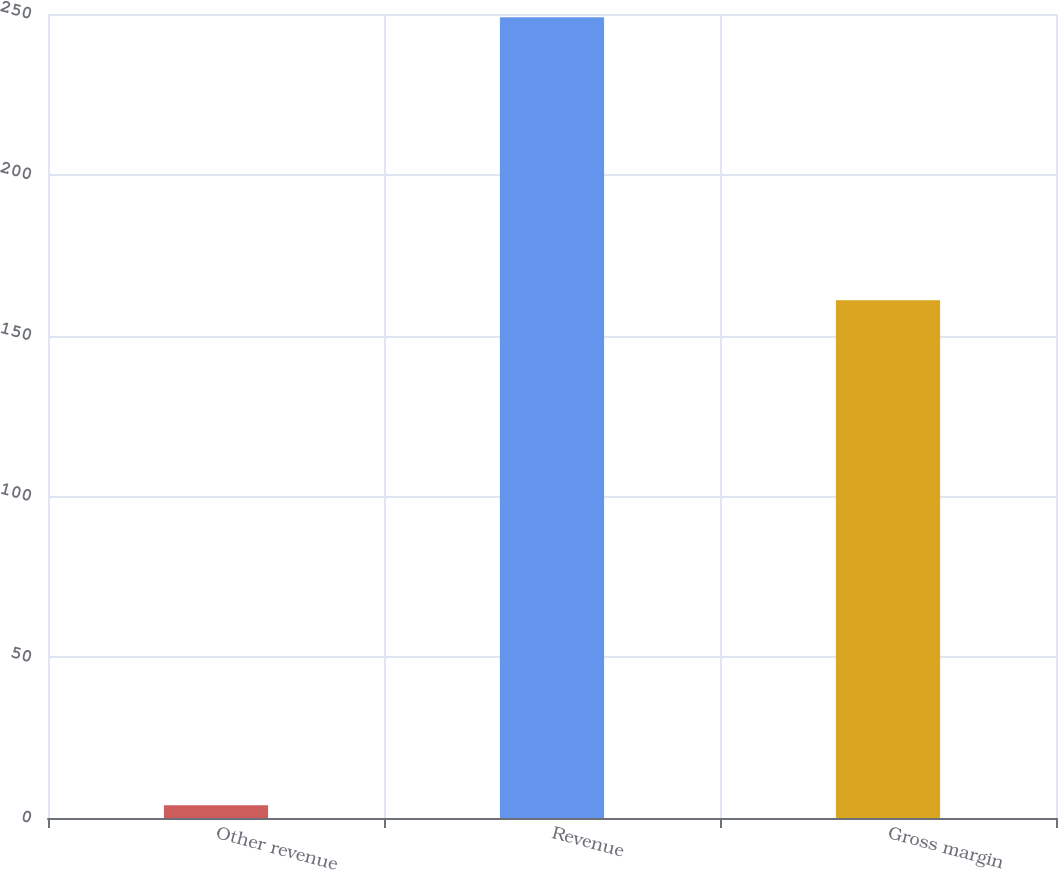Convert chart. <chart><loc_0><loc_0><loc_500><loc_500><bar_chart><fcel>Other revenue<fcel>Revenue<fcel>Gross margin<nl><fcel>4<fcel>249<fcel>161<nl></chart> 